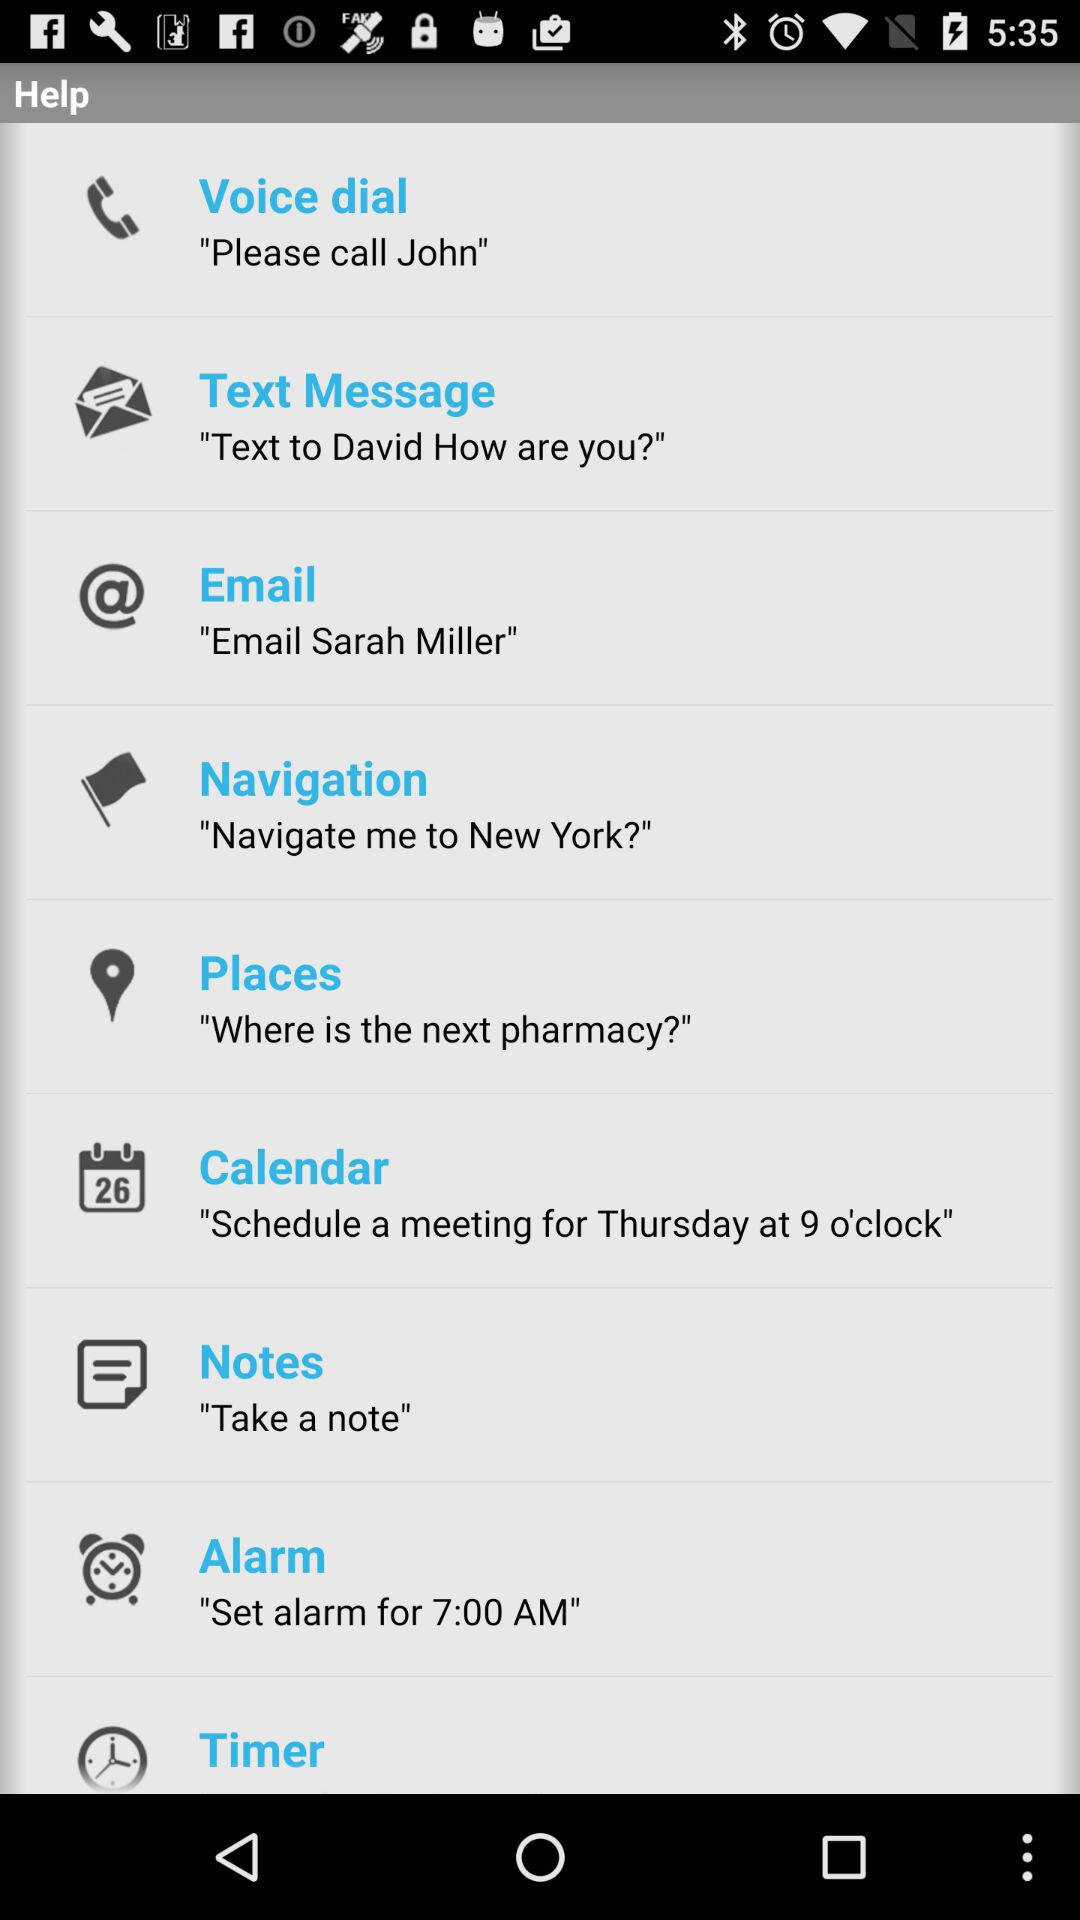What is the voice dial name?
When the provided information is insufficient, respond with <no answer>. <no answer> 